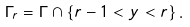Convert formula to latex. <formula><loc_0><loc_0><loc_500><loc_500>\Gamma _ { r } = \Gamma \cap \{ r - 1 < y < r \} \, .</formula> 